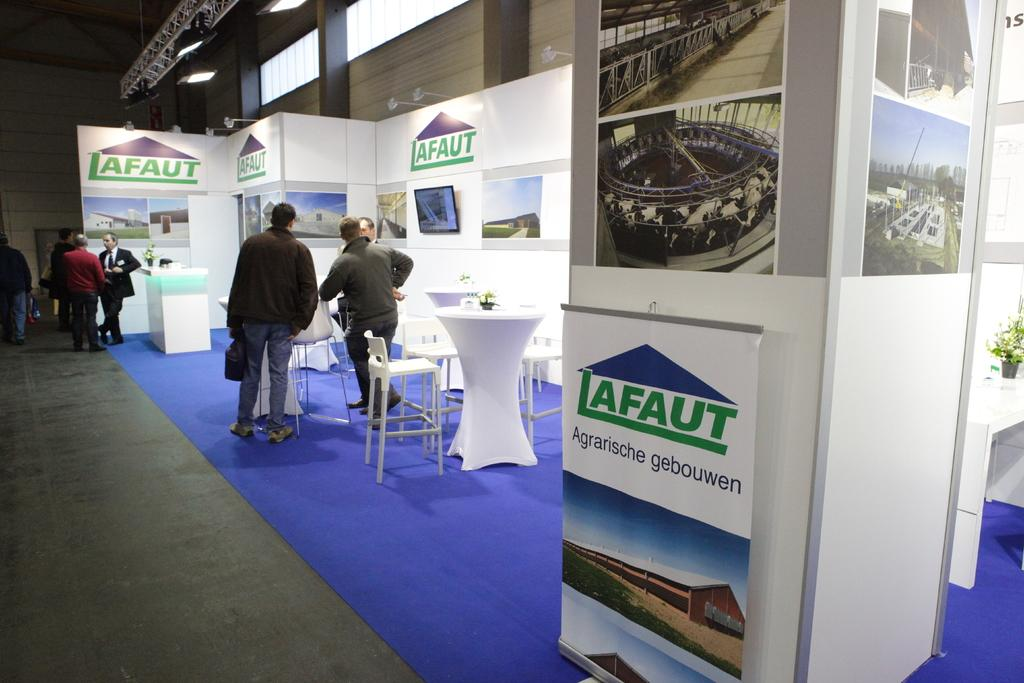<image>
Render a clear and concise summary of the photo. A booth is set up with tables and chairs for a convention, advertising Lafaut Agrarische gebouwen. 